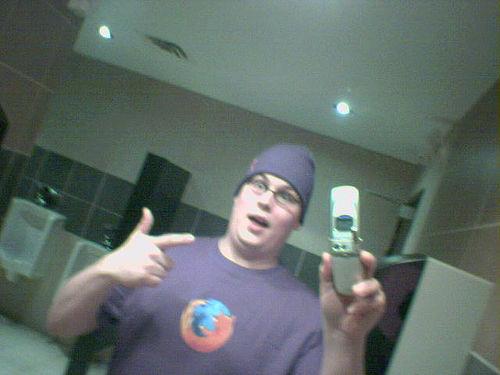What is the man holding?
Answer briefly. Phone. Where was this picture taken?
Give a very brief answer. Bathroom. What is the logo on his shirt?
Answer briefly. Firefox. 